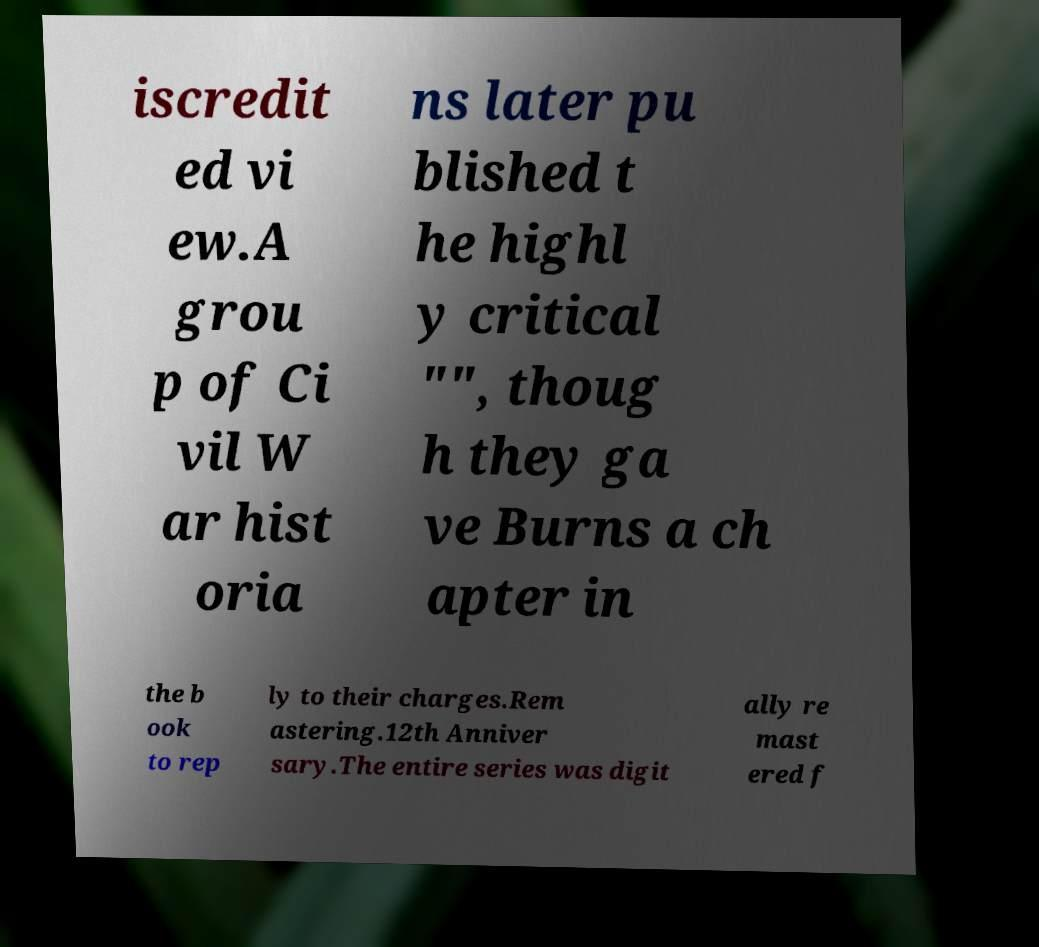There's text embedded in this image that I need extracted. Can you transcribe it verbatim? iscredit ed vi ew.A grou p of Ci vil W ar hist oria ns later pu blished t he highl y critical "", thoug h they ga ve Burns a ch apter in the b ook to rep ly to their charges.Rem astering.12th Anniver sary.The entire series was digit ally re mast ered f 